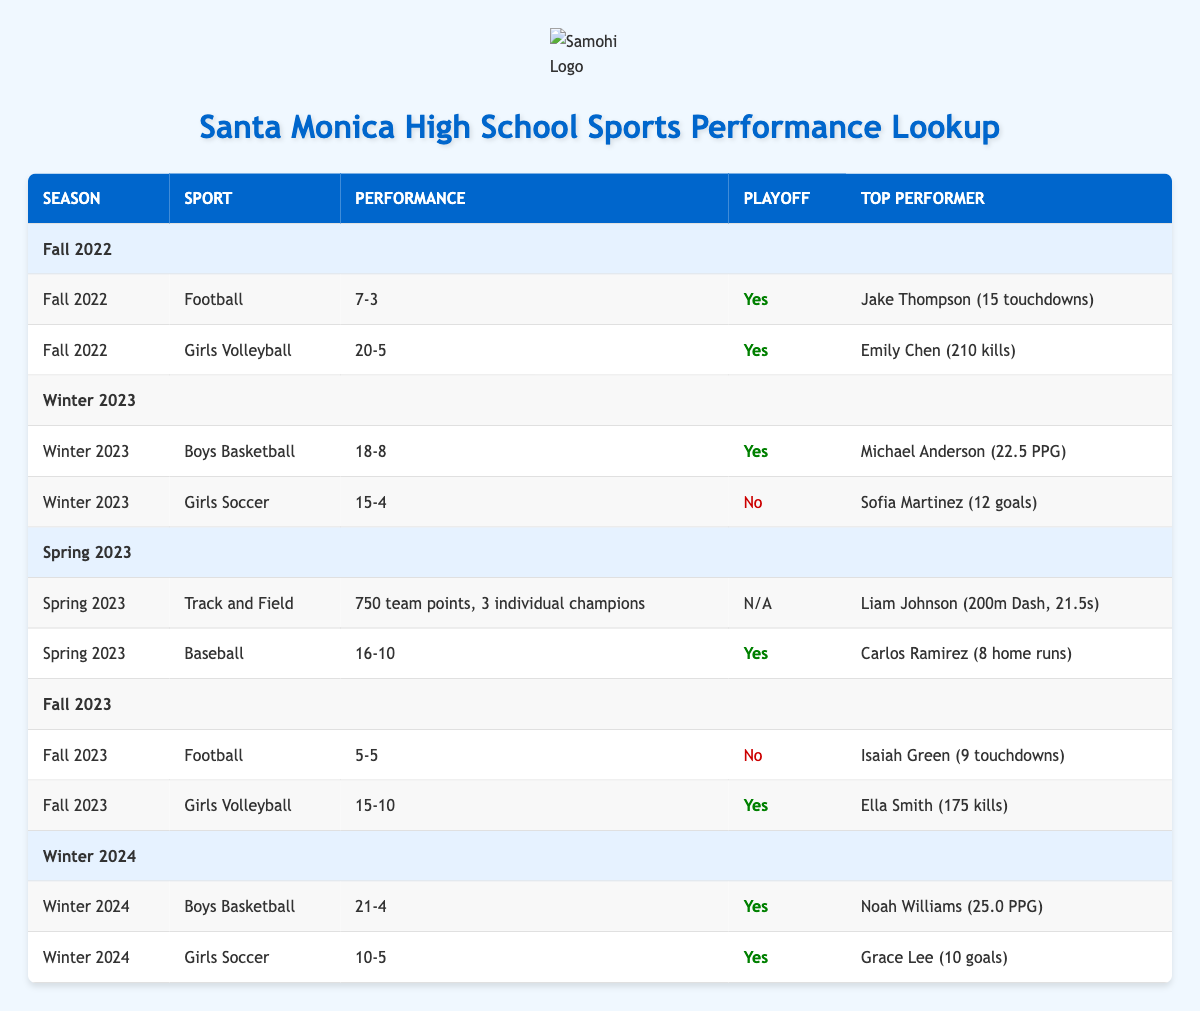What was the Football win-loss record in Fall 2022? The win-loss record for Football in Fall 2022 is listed in the table as 7 wins and 3 losses.
Answer: 7-3 Did the Girls Volleyball team make the playoffs in Fall 2023? The table indicates that the Girls Volleyball team had a playoff appearance in Fall 2023, as denoted by "Yes" in the playoff column.
Answer: Yes What is the total number of wins for Boys Basketball across Winter 2023 and Winter 2024? The table shows that Boys Basketball had 18 wins in Winter 2023 and 21 wins in Winter 2024. Adding these gives a total of 18 + 21 = 39 wins.
Answer: 39 Who was the highest scorer for Girls Soccer in Winter 2023? According to the table, Sofia Martinez was reported as the highest scorer for Girls Soccer in Winter 2023 with 12 goals.
Answer: Sofia Martinez Was there a season where Girls Soccer did not appear in playoffs? The table shows that Girls Soccer did not make the playoffs in Winter 2023, indicated by "No" in the playoff column.
Answer: Yes How many more losses did the Football team have compared to the Girls Volleyball team in Fall 2022? In Fall 2022, Football had 3 losses and Girls Volleyball had 5 losses; to find the difference, subtract 3 from 5. So, 5 - 3 = 2 more losses for Girls Volleyball than Football.
Answer: 2 What was the top performance for Track and Field in Spring 2023? The highest performer in Track and Field during Spring 2023 was Liam Johnson, who competed in the 200m Dash with a time of 21.5 seconds, as specified in the table.
Answer: Liam Johnson (200m Dash, 21.5s) Which sport had the highest number of wins in Fall 2022? In Fall 2022, Girls Volleyball recorded the highest number of wins at 20, compared to Football's 7 wins.
Answer: Girls Volleyball How many individual champions did Track and Field have in Spring 2023? The table indicates that Track and Field had 3 individual champions during Spring 2023.
Answer: 3 